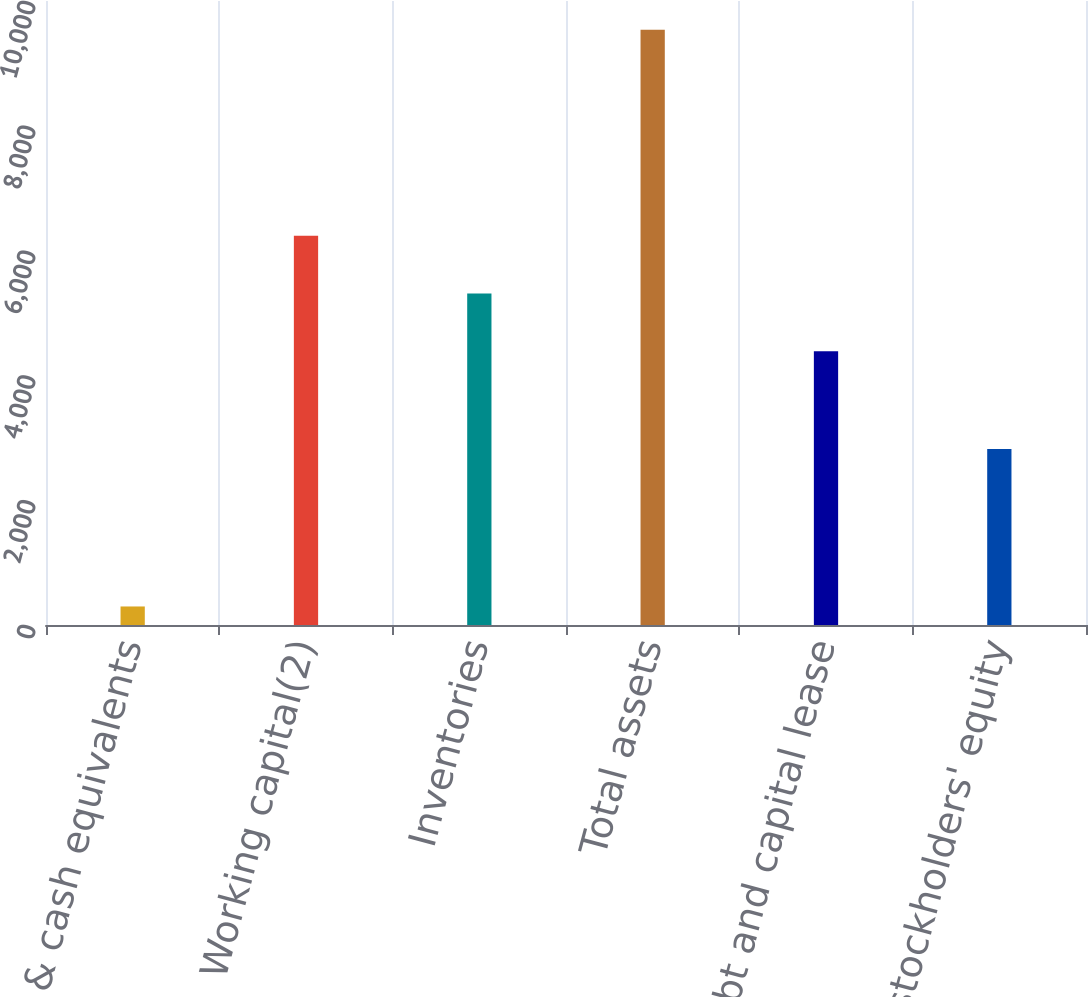Convert chart to OTSL. <chart><loc_0><loc_0><loc_500><loc_500><bar_chart><fcel>Cash & cash equivalents<fcel>Working capital(2)<fcel>Inventories<fcel>Total assets<fcel>Total debt and capital lease<fcel>Total stockholders' equity<nl><fcel>297<fcel>6236.4<fcel>5312.2<fcel>9539<fcel>4388<fcel>2822<nl></chart> 